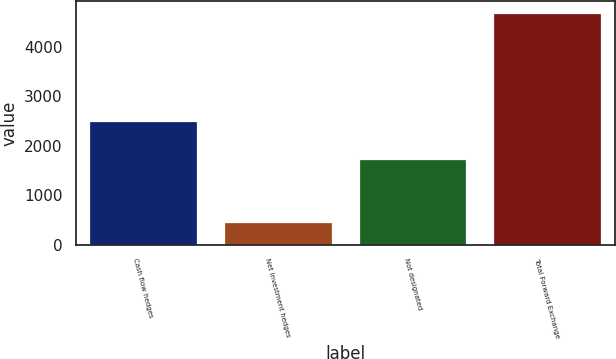Convert chart to OTSL. <chart><loc_0><loc_0><loc_500><loc_500><bar_chart><fcel>Cash flow hedges<fcel>Net investment hedges<fcel>Not designated<fcel>Total Forward Exchange<nl><fcel>2489.1<fcel>457.5<fcel>1736.1<fcel>4682.7<nl></chart> 